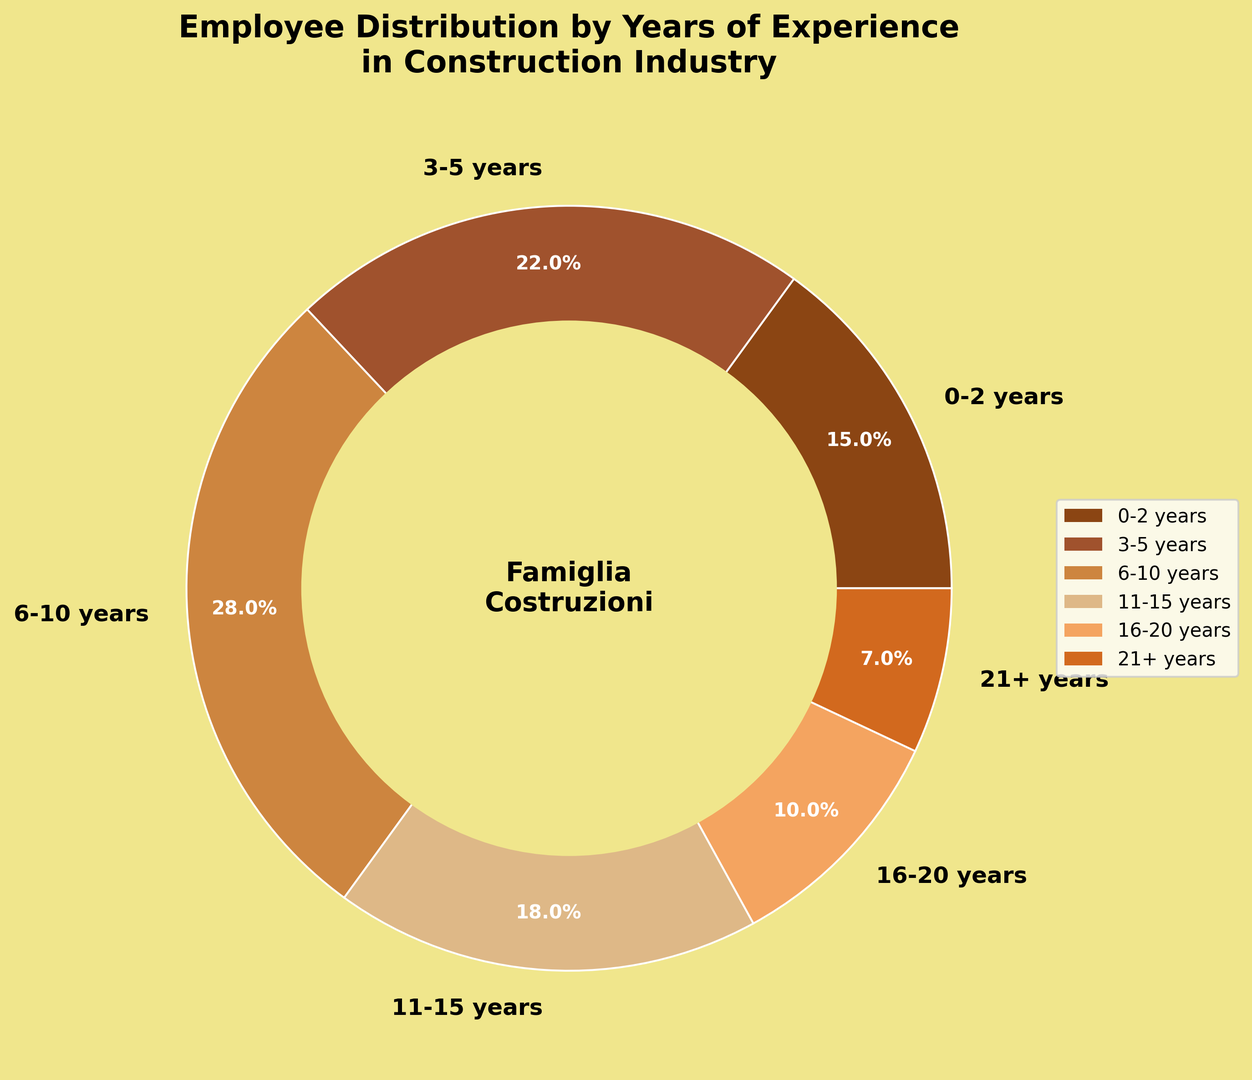What is the percentage of employees with 6-10 years of experience? The ring chart slices include percentages for each experience segment. Locate the slice labeled "6-10 years" to find the corresponding percentage.
Answer: 28% Which experience group has the highest percentage of employees? Look at each slice and its corresponding percentage value. Identify the largest percentage.
Answer: 6-10 years What is the total percentage of employees with more than 10 years of experience? Sum the percentages of the "11-15 years", "16-20 years", and "21+ years" categories. The individual percentages are 18%, 10%, and 7%. Adding them gives 18 + 10 + 7 = 35%.
Answer: 35% How does the percentage of employees with 3-5 years of experience compare with those having 11-15 years of experience? Find the percentages for both "3-5 years" and "11-15 years" categories. Compare them directly. The "3-5 years" category is 22%, and the "11-15 years" category is 18%.
Answer: 22% is greater than 18% What percentage of employees have 0-5 years of experience? Add the percentages of the "0-2 years" and "3-5 years" categories. The individual percentages are 15% and 22%. Summing these gives 15 + 22 = 37%.
Answer: 37% If an employee is randomly selected, what is the probability that the person has 21+ years of experience? The percentage corresponding to the "21+ years" category is 7%. This number represents the probability when expressed as a percentage.
Answer: 7% What color represents the segment for employees with 16-20 years of experience? Look at the ring chart and find the slice labeled "16-20 years." Identify its color visually.
Answer: Light brown How does the combined percentage of employees with 0-2 years and 21+ years of experience compare with that of employees with 6-10 years of experience? Add percentages of the "0-2 years" and "21+ years" categories (15% + 7% = 22%). Compare this result with the percentage of the "6-10 years" category (28%).
Answer: 22% is less than 28% What is the least represented experience group? Identify the slice with the smallest percentage value. The "21+ years" category has the smallest percentage, 7%.
Answer: 21+ years What proportion of employees falls within the 3-5 years and 11-15 years categories combined? Add the percentages of "3-5 years" and "11-15 years." The individual percentages are 22% and 18%. Summing these gives 22 + 18 = 40%.
Answer: 40% 